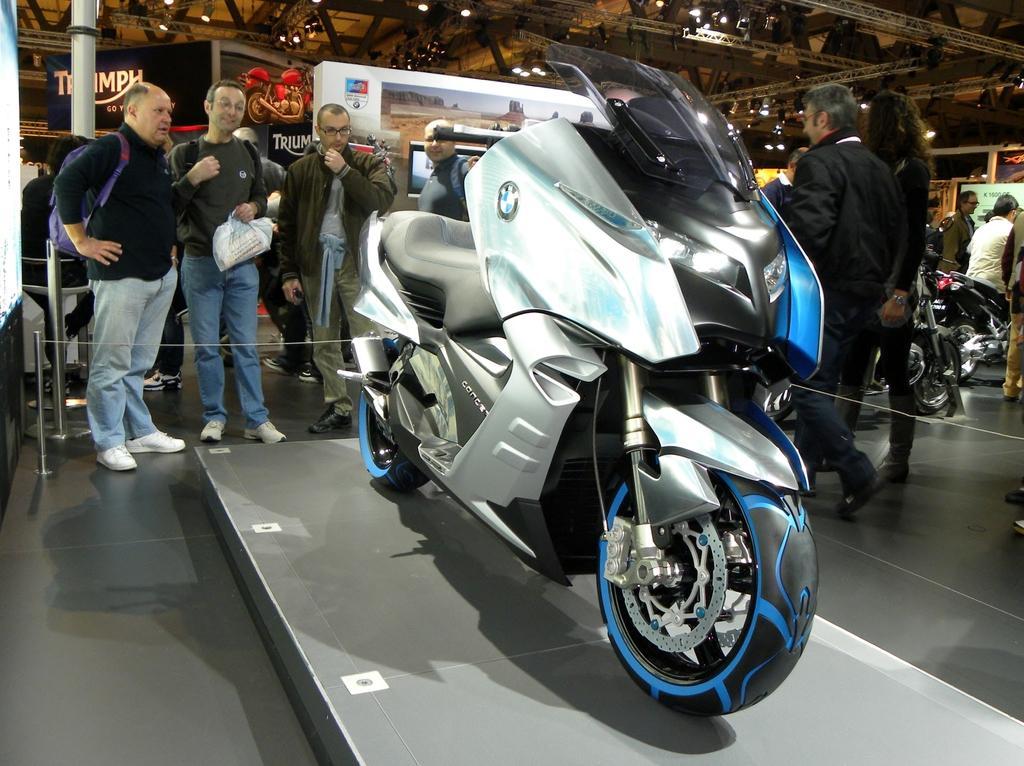Could you give a brief overview of what you see in this image? In this picture there is a motor bicycle. There are some people who are standing at the background. There is a man sitting on the motor bicycle. There is a light. 